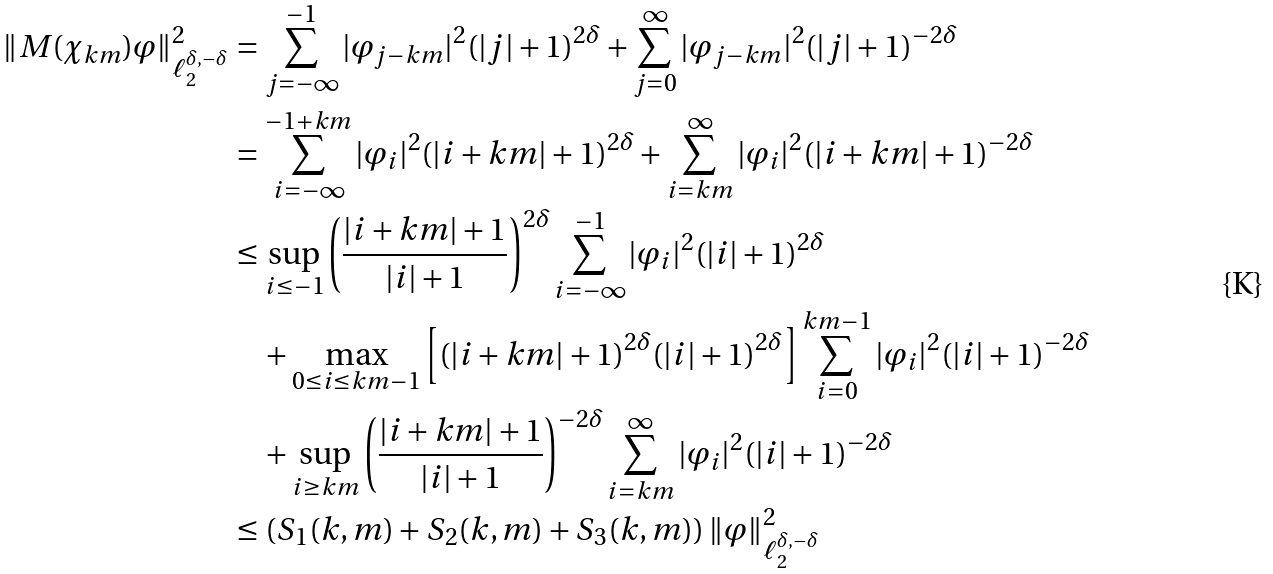Convert formula to latex. <formula><loc_0><loc_0><loc_500><loc_500>\| M ( \chi _ { k m } ) \varphi \| _ { \ell _ { 2 } ^ { \delta , - \delta } } ^ { 2 } & = \sum _ { j = - \infty } ^ { - 1 } | \varphi _ { j - k m } | ^ { 2 } ( | j | + 1 ) ^ { 2 \delta } + \sum _ { j = 0 } ^ { \infty } | \varphi _ { j - k m } | ^ { 2 } ( | j | + 1 ) ^ { - 2 \delta } \\ & = \sum _ { i = - \infty } ^ { - 1 + k m } | \varphi _ { i } | ^ { 2 } ( | i + k m | + 1 ) ^ { 2 \delta } + \sum _ { i = k m } ^ { \infty } | \varphi _ { i } | ^ { 2 } ( | i + k m | + 1 ) ^ { - 2 \delta } \\ & \leq \sup _ { i \leq - 1 } \left ( \frac { | i + k m | + 1 } { | i | + 1 } \right ) ^ { 2 \delta } \sum _ { i = - \infty } ^ { - 1 } | \varphi _ { i } | ^ { 2 } ( | i | + 1 ) ^ { 2 \delta } \\ & \quad + \max _ { 0 \leq i \leq k m - 1 } \left [ ( | i + k m | + 1 ) ^ { 2 \delta } ( | i | + 1 ) ^ { 2 \delta } \right ] \sum _ { i = 0 } ^ { k m - 1 } | \varphi _ { i } | ^ { 2 } ( | i | + 1 ) ^ { - 2 \delta } \\ & \quad + \sup _ { i \geq k m } \left ( \frac { | i + k m | + 1 } { | i | + 1 } \right ) ^ { - 2 \delta } \sum _ { i = k m } ^ { \infty } | \varphi _ { i } | ^ { 2 } ( | i | + 1 ) ^ { - 2 \delta } \\ & \leq \left ( S _ { 1 } ( k , m ) + S _ { 2 } ( k , m ) + S _ { 3 } ( k , m ) \right ) \| \varphi \| _ { \ell _ { 2 } ^ { \delta , - \delta } } ^ { 2 }</formula> 